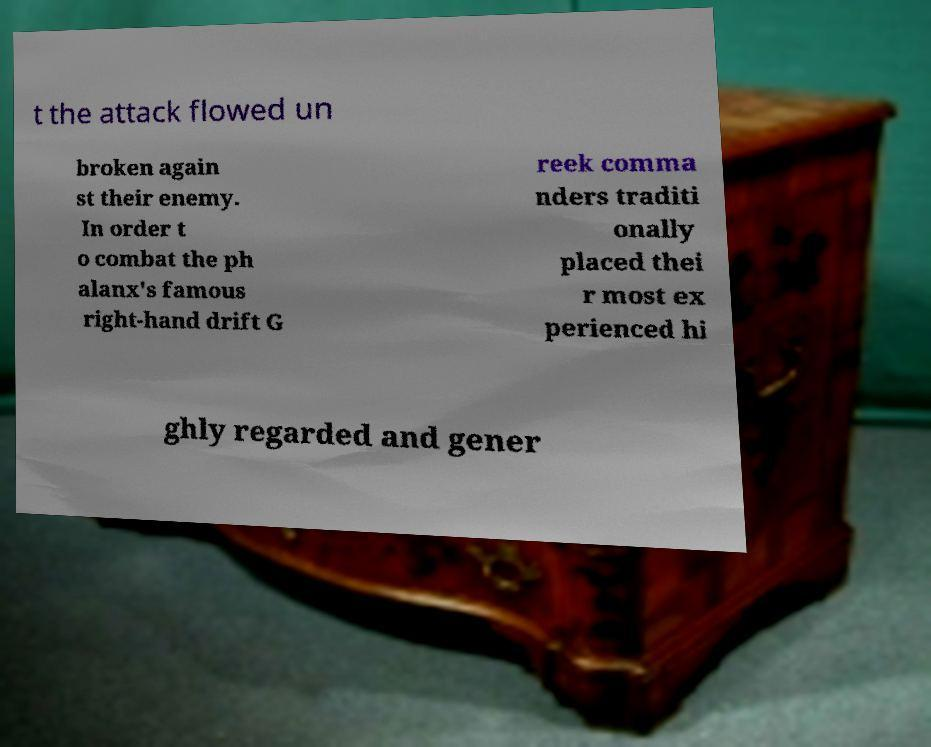Can you read and provide the text displayed in the image?This photo seems to have some interesting text. Can you extract and type it out for me? t the attack flowed un broken again st their enemy. In order t o combat the ph alanx's famous right-hand drift G reek comma nders traditi onally placed thei r most ex perienced hi ghly regarded and gener 